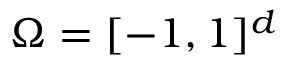<formula> <loc_0><loc_0><loc_500><loc_500>\Omega = [ - 1 , 1 ] ^ { d }</formula> 